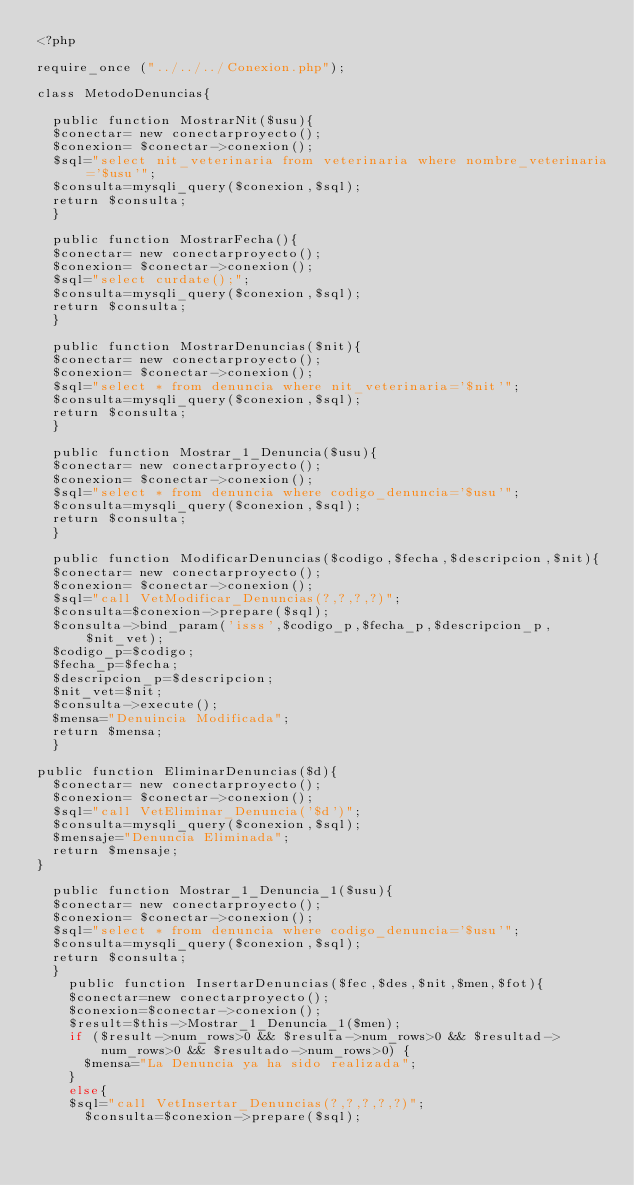<code> <loc_0><loc_0><loc_500><loc_500><_PHP_><?php

require_once ("../../../Conexion.php");

class MetodoDenuncias{
	
	public function MostrarNit($usu){
	$conectar= new conectarproyecto();
	$conexion= $conectar->conexion();
	$sql="select nit_veterinaria from veterinaria where nombre_veterinaria='$usu'";
	$consulta=mysqli_query($conexion,$sql);
	return $consulta;
	}
	
	public function MostrarFecha(){
	$conectar= new conectarproyecto();
	$conexion= $conectar->conexion();
	$sql="select curdate();";
	$consulta=mysqli_query($conexion,$sql);
	return $consulta;
	}

	public function MostrarDenuncias($nit){
	$conectar= new conectarproyecto();
	$conexion= $conectar->conexion();
	$sql="select * from denuncia where nit_veterinaria='$nit'";
	$consulta=mysqli_query($conexion,$sql);
	return $consulta;
	}

	public function Mostrar_1_Denuncia($usu){
	$conectar= new conectarproyecto();
	$conexion= $conectar->conexion();
	$sql="select * from denuncia where codigo_denuncia='$usu'";
	$consulta=mysqli_query($conexion,$sql);
	return $consulta;
	}

	public function ModificarDenuncias($codigo,$fecha,$descripcion,$nit){
	$conectar= new conectarproyecto();
	$conexion= $conectar->conexion();
	$sql="call VetModificar_Denuncias(?,?,?,?)";
	$consulta=$conexion->prepare($sql);
	$consulta->bind_param('isss',$codigo_p,$fecha_p,$descripcion_p,$nit_vet);
	$codigo_p=$codigo;
	$fecha_p=$fecha;
	$descripcion_p=$descripcion;
	$nit_vet=$nit;
	$consulta->execute();
	$mensa="Denuincia Modificada";
	return $mensa;
	}

public function EliminarDenuncias($d){
	$conectar= new conectarproyecto();
	$conexion= $conectar->conexion();
	$sql="call VetEliminar_Denuncia('$d')";
	$consulta=mysqli_query($conexion,$sql);
	$mensaje="Denuncia Eliminada";
	return $mensaje; 
}

	public function Mostrar_1_Denuncia_1($usu){
	$conectar= new conectarproyecto();
	$conexion= $conectar->conexion();
	$sql="select * from denuncia where codigo_denuncia='$usu'";
	$consulta=mysqli_query($conexion,$sql);
	return $consulta;
	}
		public function InsertarDenuncias($fec,$des,$nit,$men,$fot){
		$conectar=new conectarproyecto();
		$conexion=$conectar->conexion();
		$result=$this->Mostrar_1_Denuncia_1($men);
		if ($result->num_rows>0 && $resulta->num_rows>0 && $resultad->num_rows>0 && $resultado->num_rows>0) {
			$mensa="La Denuncia ya ha sido realizada";
		}
		else{
		$sql="call VetInsertar_Denuncias(?,?,?,?,?)";
			$consulta=$conexion->prepare($sql);</code> 